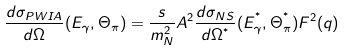Convert formula to latex. <formula><loc_0><loc_0><loc_500><loc_500>\frac { d \sigma _ { P W I A } } { d \Omega } ( E _ { \gamma } , \Theta _ { \pi } ) = \frac { s } { m _ { N } ^ { 2 } } A ^ { 2 } \frac { d \sigma _ { N S } } { d \Omega ^ { ^ { * } } } ( E ^ { ^ { * } } _ { \gamma } , \Theta _ { \pi } ^ { ^ { * } } ) F ^ { 2 } ( q )</formula> 